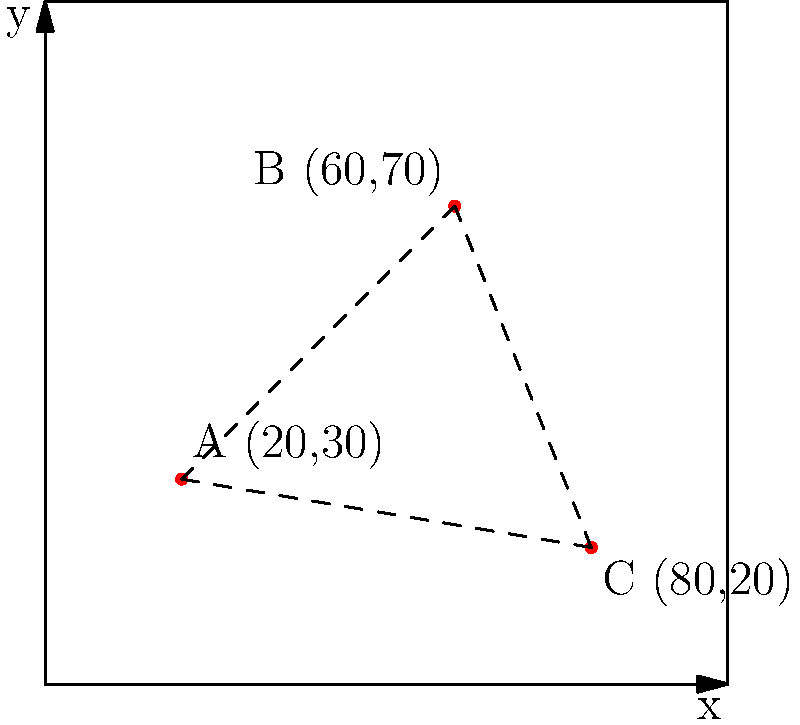Given the race course map with three nutrition stations A(20,30), B(60,70), and C(80,20), what is the total distance between all stations if runners must travel in a straight line from one station to the next in the order A → B → C → A? Round your answer to the nearest whole number. To solve this problem, we need to calculate the distances between each pair of stations and sum them up. We'll use the distance formula between two points: $d = \sqrt{(x_2-x_1)^2 + (y_2-y_1)^2}$

Step 1: Calculate distance from A to B
$d_{AB} = \sqrt{(60-20)^2 + (70-30)^2} = \sqrt{40^2 + 40^2} = \sqrt{3200} \approx 56.57$

Step 2: Calculate distance from B to C
$d_{BC} = \sqrt{(80-60)^2 + (20-70)^2} = \sqrt{20^2 + (-50)^2} = \sqrt{2900} \approx 53.85$

Step 3: Calculate distance from C to A
$d_{CA} = \sqrt{(20-80)^2 + (30-20)^2} = \sqrt{(-60)^2 + 10^2} = \sqrt{3700} \approx 60.83$

Step 4: Sum up all distances
Total distance = $d_{AB} + d_{BC} + d_{CA} = 56.57 + 53.85 + 60.83 = 171.25$

Step 5: Round to the nearest whole number
171.25 rounds to 171

Therefore, the total distance between all stations, traveling in the order A → B → C → A, is approximately 171 units.
Answer: 171 units 